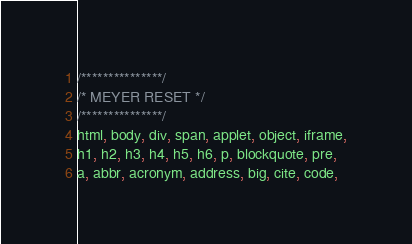Convert code to text. <code><loc_0><loc_0><loc_500><loc_500><_CSS_>/***************/
/* MEYER RESET */
/***************/
html, body, div, span, applet, object, iframe,
h1, h2, h3, h4, h5, h6, p, blockquote, pre,
a, abbr, acronym, address, big, cite, code,</code> 